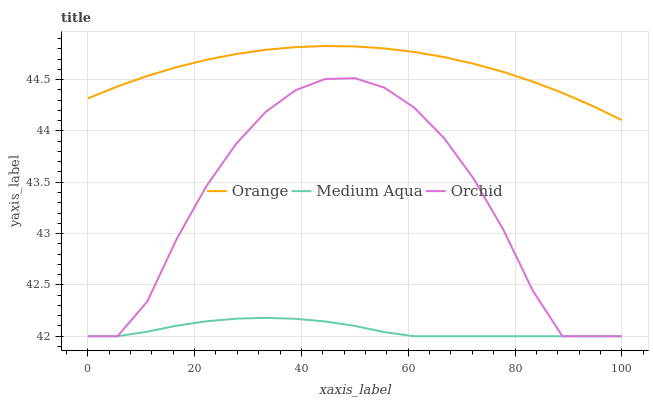Does Medium Aqua have the minimum area under the curve?
Answer yes or no. Yes. Does Orange have the maximum area under the curve?
Answer yes or no. Yes. Does Orchid have the minimum area under the curve?
Answer yes or no. No. Does Orchid have the maximum area under the curve?
Answer yes or no. No. Is Medium Aqua the smoothest?
Answer yes or no. Yes. Is Orchid the roughest?
Answer yes or no. Yes. Is Orchid the smoothest?
Answer yes or no. No. Is Medium Aqua the roughest?
Answer yes or no. No. Does Medium Aqua have the lowest value?
Answer yes or no. Yes. Does Orange have the highest value?
Answer yes or no. Yes. Does Orchid have the highest value?
Answer yes or no. No. Is Medium Aqua less than Orange?
Answer yes or no. Yes. Is Orange greater than Medium Aqua?
Answer yes or no. Yes. Does Medium Aqua intersect Orchid?
Answer yes or no. Yes. Is Medium Aqua less than Orchid?
Answer yes or no. No. Is Medium Aqua greater than Orchid?
Answer yes or no. No. Does Medium Aqua intersect Orange?
Answer yes or no. No. 